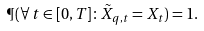Convert formula to latex. <formula><loc_0><loc_0><loc_500><loc_500>\P ( \forall \, t \in [ 0 , T ] \colon \tilde { X } _ { q , t } = X _ { t } ) = 1 .</formula> 